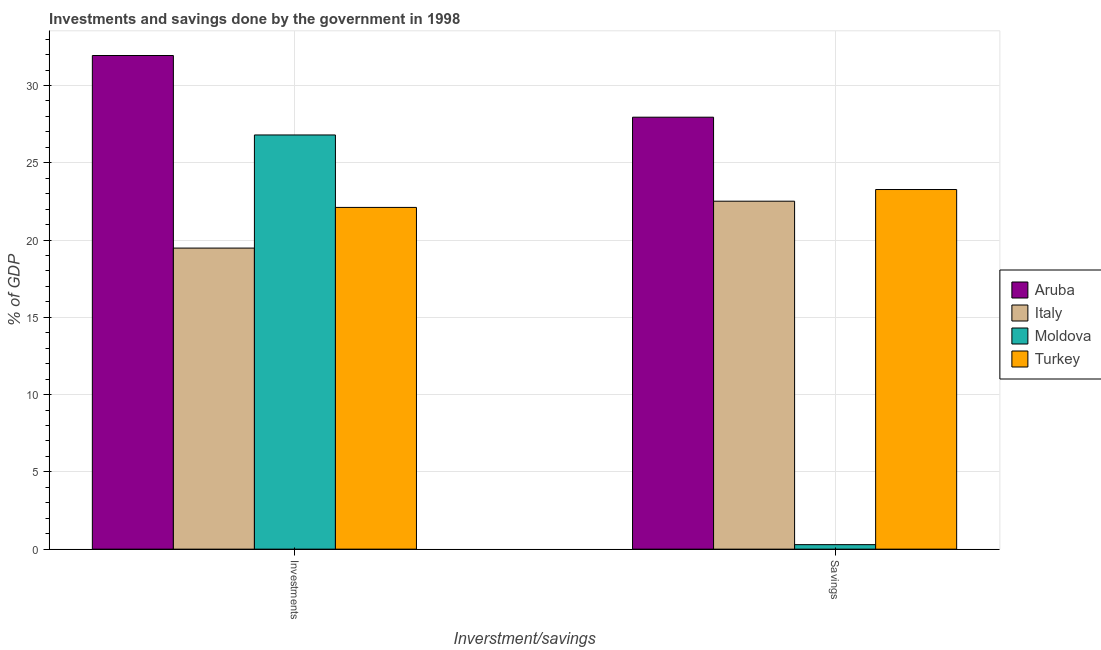How many groups of bars are there?
Provide a succinct answer. 2. Are the number of bars per tick equal to the number of legend labels?
Your answer should be very brief. Yes. Are the number of bars on each tick of the X-axis equal?
Provide a short and direct response. Yes. How many bars are there on the 2nd tick from the left?
Your answer should be very brief. 4. How many bars are there on the 2nd tick from the right?
Give a very brief answer. 4. What is the label of the 2nd group of bars from the left?
Your answer should be very brief. Savings. What is the investments of government in Aruba?
Offer a very short reply. 31.94. Across all countries, what is the maximum investments of government?
Make the answer very short. 31.94. Across all countries, what is the minimum investments of government?
Offer a very short reply. 19.48. In which country was the savings of government maximum?
Make the answer very short. Aruba. In which country was the investments of government minimum?
Offer a very short reply. Italy. What is the total savings of government in the graph?
Your answer should be very brief. 74.03. What is the difference between the savings of government in Turkey and that in Italy?
Give a very brief answer. 0.75. What is the difference between the investments of government in Italy and the savings of government in Moldova?
Provide a short and direct response. 19.19. What is the average investments of government per country?
Offer a very short reply. 25.08. What is the difference between the savings of government and investments of government in Turkey?
Give a very brief answer. 1.16. What is the ratio of the investments of government in Italy to that in Moldova?
Provide a succinct answer. 0.73. Is the savings of government in Italy less than that in Moldova?
Make the answer very short. No. What does the 2nd bar from the right in Investments represents?
Offer a terse response. Moldova. Are all the bars in the graph horizontal?
Keep it short and to the point. No. How many countries are there in the graph?
Make the answer very short. 4. What is the difference between two consecutive major ticks on the Y-axis?
Provide a short and direct response. 5. Are the values on the major ticks of Y-axis written in scientific E-notation?
Your answer should be very brief. No. Does the graph contain grids?
Provide a succinct answer. Yes. Where does the legend appear in the graph?
Offer a terse response. Center right. How are the legend labels stacked?
Your answer should be compact. Vertical. What is the title of the graph?
Offer a very short reply. Investments and savings done by the government in 1998. Does "Sweden" appear as one of the legend labels in the graph?
Keep it short and to the point. No. What is the label or title of the X-axis?
Your response must be concise. Inverstment/savings. What is the label or title of the Y-axis?
Give a very brief answer. % of GDP. What is the % of GDP in Aruba in Investments?
Provide a short and direct response. 31.94. What is the % of GDP in Italy in Investments?
Ensure brevity in your answer.  19.48. What is the % of GDP of Moldova in Investments?
Make the answer very short. 26.8. What is the % of GDP in Turkey in Investments?
Your response must be concise. 22.11. What is the % of GDP in Aruba in Savings?
Make the answer very short. 27.95. What is the % of GDP in Italy in Savings?
Make the answer very short. 22.52. What is the % of GDP of Moldova in Savings?
Offer a very short reply. 0.29. What is the % of GDP in Turkey in Savings?
Provide a succinct answer. 23.27. Across all Inverstment/savings, what is the maximum % of GDP in Aruba?
Your answer should be very brief. 31.94. Across all Inverstment/savings, what is the maximum % of GDP in Italy?
Your answer should be compact. 22.52. Across all Inverstment/savings, what is the maximum % of GDP in Moldova?
Your answer should be very brief. 26.8. Across all Inverstment/savings, what is the maximum % of GDP in Turkey?
Your answer should be very brief. 23.27. Across all Inverstment/savings, what is the minimum % of GDP in Aruba?
Your response must be concise. 27.95. Across all Inverstment/savings, what is the minimum % of GDP of Italy?
Your answer should be very brief. 19.48. Across all Inverstment/savings, what is the minimum % of GDP in Moldova?
Keep it short and to the point. 0.29. Across all Inverstment/savings, what is the minimum % of GDP of Turkey?
Your answer should be very brief. 22.11. What is the total % of GDP in Aruba in the graph?
Your response must be concise. 59.89. What is the total % of GDP in Italy in the graph?
Provide a short and direct response. 42. What is the total % of GDP of Moldova in the graph?
Provide a succinct answer. 27.09. What is the total % of GDP in Turkey in the graph?
Your answer should be compact. 45.38. What is the difference between the % of GDP in Aruba in Investments and that in Savings?
Offer a terse response. 3.99. What is the difference between the % of GDP of Italy in Investments and that in Savings?
Your response must be concise. -3.03. What is the difference between the % of GDP of Moldova in Investments and that in Savings?
Keep it short and to the point. 26.51. What is the difference between the % of GDP in Turkey in Investments and that in Savings?
Your response must be concise. -1.16. What is the difference between the % of GDP in Aruba in Investments and the % of GDP in Italy in Savings?
Ensure brevity in your answer.  9.43. What is the difference between the % of GDP in Aruba in Investments and the % of GDP in Moldova in Savings?
Provide a short and direct response. 31.65. What is the difference between the % of GDP in Aruba in Investments and the % of GDP in Turkey in Savings?
Offer a very short reply. 8.67. What is the difference between the % of GDP of Italy in Investments and the % of GDP of Moldova in Savings?
Offer a very short reply. 19.19. What is the difference between the % of GDP in Italy in Investments and the % of GDP in Turkey in Savings?
Your answer should be compact. -3.79. What is the difference between the % of GDP of Moldova in Investments and the % of GDP of Turkey in Savings?
Give a very brief answer. 3.53. What is the average % of GDP of Aruba per Inverstment/savings?
Make the answer very short. 29.95. What is the average % of GDP in Italy per Inverstment/savings?
Give a very brief answer. 21. What is the average % of GDP of Moldova per Inverstment/savings?
Your response must be concise. 13.55. What is the average % of GDP in Turkey per Inverstment/savings?
Provide a succinct answer. 22.69. What is the difference between the % of GDP of Aruba and % of GDP of Italy in Investments?
Offer a very short reply. 12.46. What is the difference between the % of GDP in Aruba and % of GDP in Moldova in Investments?
Give a very brief answer. 5.14. What is the difference between the % of GDP in Aruba and % of GDP in Turkey in Investments?
Your answer should be compact. 9.83. What is the difference between the % of GDP in Italy and % of GDP in Moldova in Investments?
Provide a short and direct response. -7.32. What is the difference between the % of GDP of Italy and % of GDP of Turkey in Investments?
Your answer should be compact. -2.63. What is the difference between the % of GDP in Moldova and % of GDP in Turkey in Investments?
Give a very brief answer. 4.69. What is the difference between the % of GDP of Aruba and % of GDP of Italy in Savings?
Provide a succinct answer. 5.43. What is the difference between the % of GDP in Aruba and % of GDP in Moldova in Savings?
Offer a very short reply. 27.66. What is the difference between the % of GDP of Aruba and % of GDP of Turkey in Savings?
Give a very brief answer. 4.68. What is the difference between the % of GDP of Italy and % of GDP of Moldova in Savings?
Your answer should be compact. 22.22. What is the difference between the % of GDP in Italy and % of GDP in Turkey in Savings?
Provide a succinct answer. -0.75. What is the difference between the % of GDP in Moldova and % of GDP in Turkey in Savings?
Make the answer very short. -22.98. What is the ratio of the % of GDP in Aruba in Investments to that in Savings?
Give a very brief answer. 1.14. What is the ratio of the % of GDP of Italy in Investments to that in Savings?
Give a very brief answer. 0.87. What is the ratio of the % of GDP of Moldova in Investments to that in Savings?
Your answer should be very brief. 92.04. What is the ratio of the % of GDP of Turkey in Investments to that in Savings?
Offer a terse response. 0.95. What is the difference between the highest and the second highest % of GDP in Aruba?
Make the answer very short. 3.99. What is the difference between the highest and the second highest % of GDP in Italy?
Offer a terse response. 3.03. What is the difference between the highest and the second highest % of GDP in Moldova?
Offer a very short reply. 26.51. What is the difference between the highest and the second highest % of GDP in Turkey?
Ensure brevity in your answer.  1.16. What is the difference between the highest and the lowest % of GDP of Aruba?
Offer a terse response. 3.99. What is the difference between the highest and the lowest % of GDP of Italy?
Make the answer very short. 3.03. What is the difference between the highest and the lowest % of GDP of Moldova?
Your response must be concise. 26.51. What is the difference between the highest and the lowest % of GDP of Turkey?
Provide a short and direct response. 1.16. 